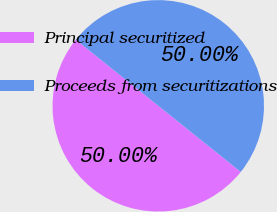<chart> <loc_0><loc_0><loc_500><loc_500><pie_chart><fcel>Principal securitized<fcel>Proceeds from securitizations<nl><fcel>50.0%<fcel>50.0%<nl></chart> 